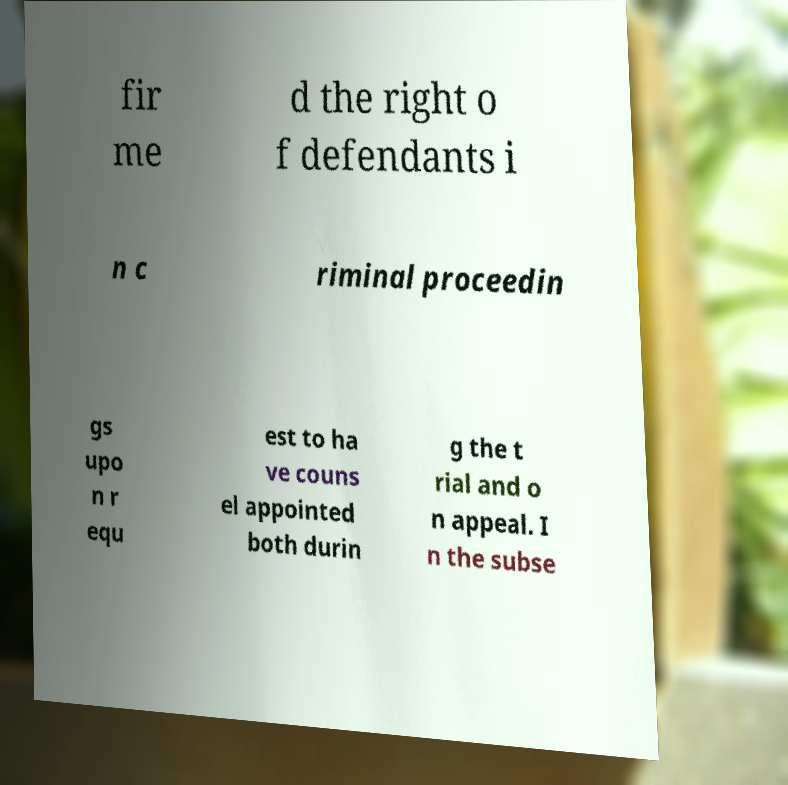Could you assist in decoding the text presented in this image and type it out clearly? fir me d the right o f defendants i n c riminal proceedin gs upo n r equ est to ha ve couns el appointed both durin g the t rial and o n appeal. I n the subse 